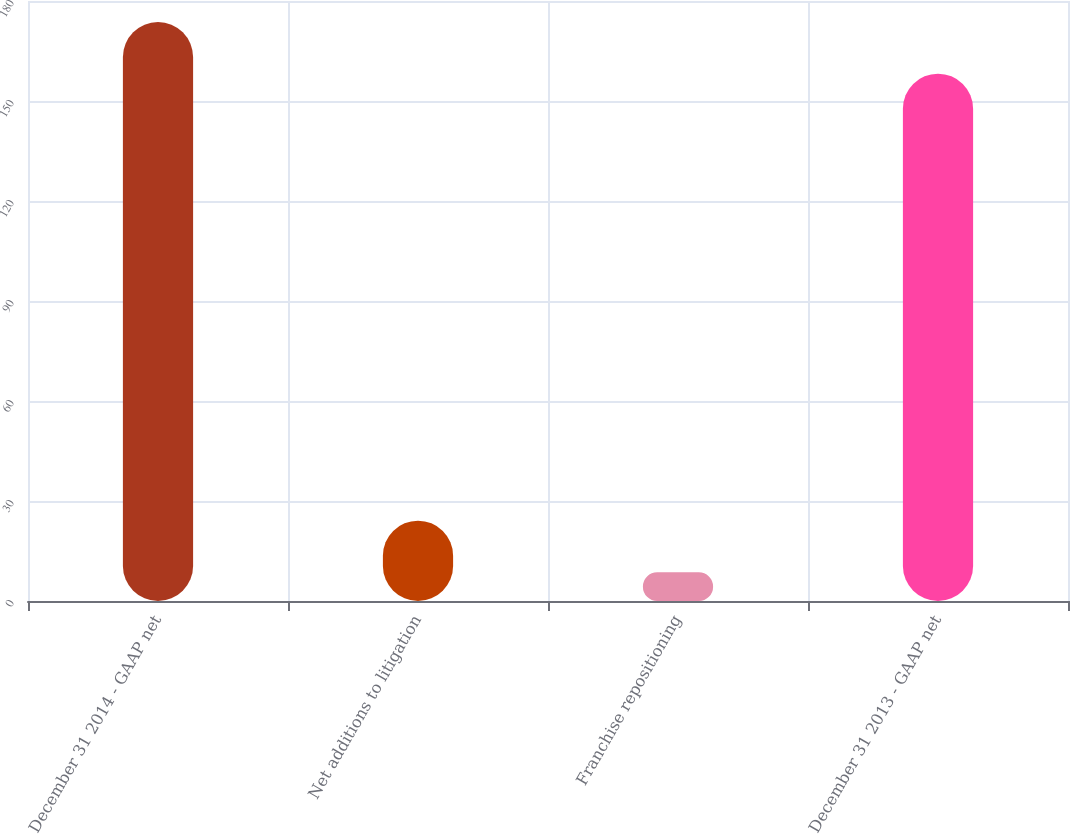<chart> <loc_0><loc_0><loc_500><loc_500><bar_chart><fcel>December 31 2014 - GAAP net<fcel>Net additions to litigation<fcel>Franchise repositioning<fcel>December 31 2013 - GAAP net<nl><fcel>173.7<fcel>24.1<fcel>8.6<fcel>158.2<nl></chart> 